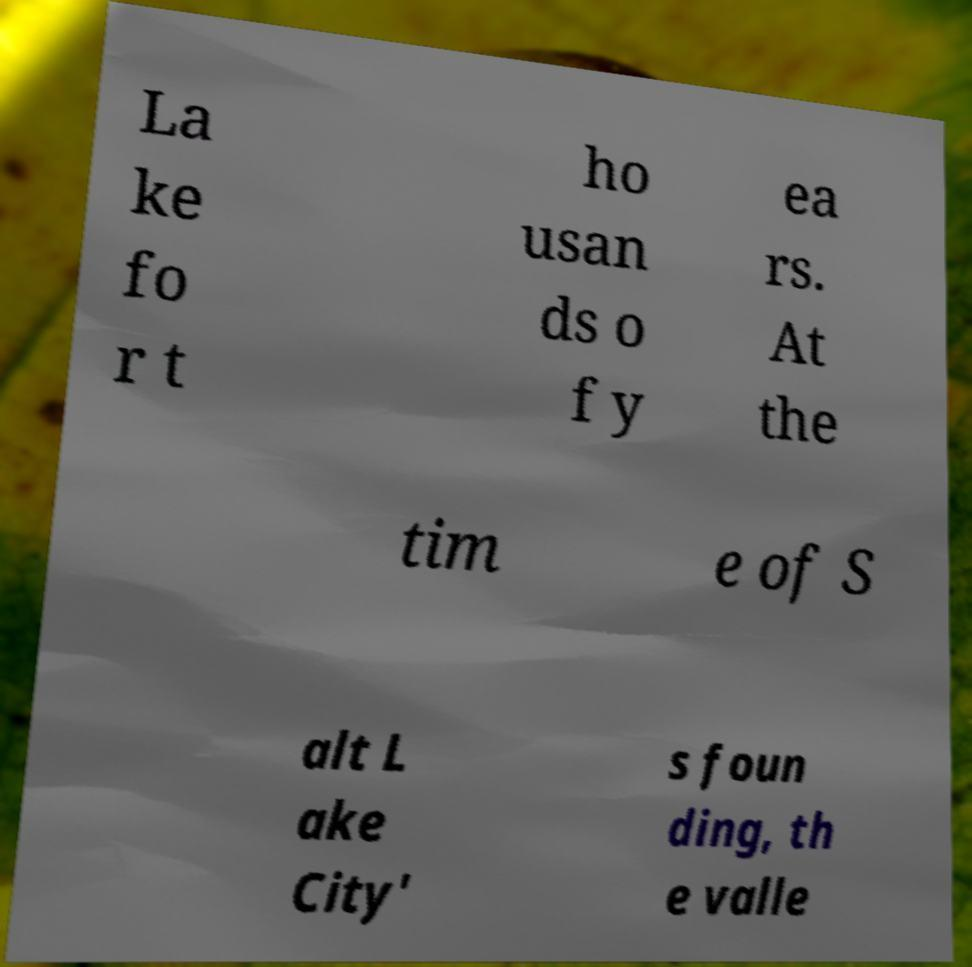Please identify and transcribe the text found in this image. La ke fo r t ho usan ds o f y ea rs. At the tim e of S alt L ake City' s foun ding, th e valle 